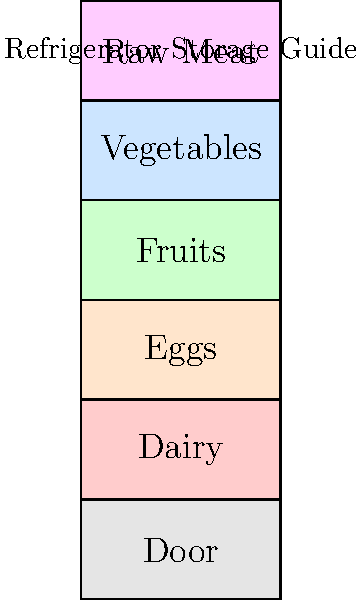Based on the color-coded diagram of refrigerator storage, which section is most suitable for storing raw chicken to prevent cross-contamination and maintain food safety? To answer this question, let's analyze the refrigerator storage guide:

1. The refrigerator is divided into six sections, each color-coded and labeled.
2. From bottom to top, we have:
   - Door (gray)
   - Dairy (light red)
   - Eggs (light yellow)
   - Fruits (light green)
   - Vegetables (light blue)
   - Raw Meat (light purple)

3. Raw chicken is considered raw meat and should be stored in a way that prevents its juices from dripping onto other foods, which can cause cross-contamination.

4. The top shelf (light purple) is labeled "Raw Meat," which is the ideal location for storing raw chicken.

5. Placing raw meat on the top shelf might seem counterintuitive, but it's actually the safest option in a well-designed refrigerator:
   - It prevents drips from contaminating other foods below.
   - The top shelf is often the coldest part of the refrigerator, which helps keep the meat at a safe temperature.

6. Other sections are designated for specific food types and would not be appropriate for raw chicken storage.

Therefore, based on the color-coded diagram, the light purple section labeled "Raw Meat" at the top of the refrigerator is the most suitable for storing raw chicken.
Answer: Raw Meat section (top shelf) 